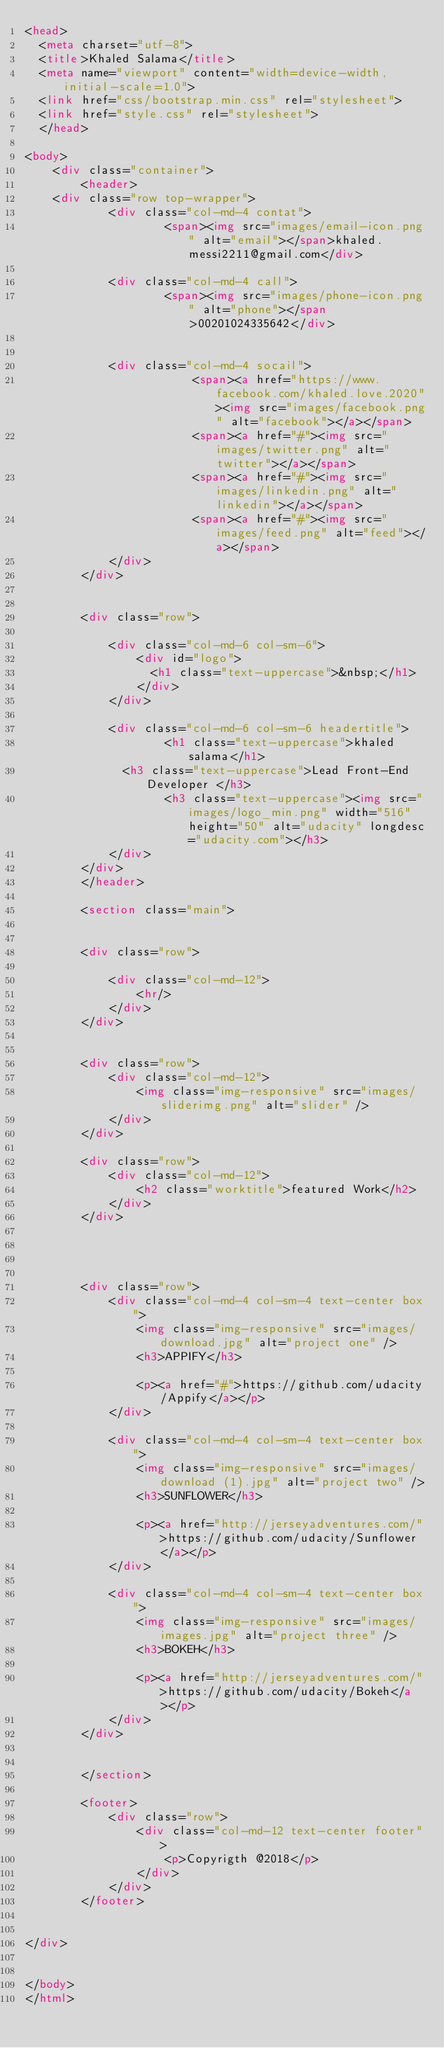Convert code to text. <code><loc_0><loc_0><loc_500><loc_500><_HTML_><head>
  <meta charset="utf-8">
  <title>Khaled Salama</title>
  <meta name="viewport" content="width=device-width, initial-scale=1.0">
  <link href="css/bootstrap.min.css" rel="stylesheet">
  <link href="style.css" rel="stylesheet">
  </head>

<body>
	<div class="container">
		<header>
	<div class="row top-wrapper">
        	<div class="col-md-4 contat">
                	<span><img src="images/email-icon.png" alt="email"></span>khaled.messi2211@gmail.com</div>
			
			<div class="col-md-4 call">
			     	<span><img src="images/phone-icon.png" alt="phone"></span>00201024335642</div>
        
            
            <div class="col-md-4 socail">
						<span><a href="https://www.facebook.com/khaled.love.2020"><img src="images/facebook.png" alt="facebook"></a></span>
                        <span><a href="#"><img src="images/twitter.png" alt="twitter"></a></span>
                        <span><a href="#"><img src="images/linkedin.png" alt="linkedin"></a></span>
                        <span><a href="#"><img src="images/feed.png" alt="feed"></a></span>
            </div>
        </div>

	
		<div class="row">
			
            <div class="col-md-6 col-sm-6">
				<div id="logo">
				  <h1 class="text-uppercase">&nbsp;</h1>
				</div>
            </div>
            
            <div class="col-md-6 col-sm-6 headertitle">
					<h1 class="text-uppercase">khaled salama</h1>
              <h3 class="text-uppercase">Lead Front-End Developer </h3>
                    <h3 class="text-uppercase"><img src="images/logo_min.png" width="516" height="50" alt="udacity" longdesc="udacity.com"></h3>
            </div>
        </div>
		</header>
		
		<section class="main">
		
			
		<div class="row">
			
            <div class="col-md-12">
				<hr/>
			</div>
		</div>
		
		
		<div class="row">
			<div class="col-md-12">
				<img class="img-responsive" src="images/sliderimg.png" alt="slider" />
			</div>
		</div>
		
		<div class="row">
			<div class="col-md-12">
				<h2 class="worktitle">featured Work</h2>
			</div>
		</div>
		
		
		
		
		<div class="row">
			<div class="col-md-4 col-sm-4 text-center box">
				<img class="img-responsive" src="images/download.jpg" alt="project one" />
				<h3>APPIFY</h3>
				
				<p><a href="#">https://github.com/udacity/Appify</a></p>
			</div>
			
			<div class="col-md-4 col-sm-4 text-center box">
				<img class="img-responsive" src="images/download (1).jpg" alt="project two" />
				<h3>SUNFLOWER</h3>
				
				<p><a href="http://jerseyadventures.com/">https://github.com/udacity/Sunflower</a></p>
			</div>
			
			<div class="col-md-4 col-sm-4 text-center box">
				<img class="img-responsive" src="images/images.jpg" alt="project three" />
				<h3>BOKEH</h3>
				
				<p><a href="http://jerseyadventures.com/">https://github.com/udacity/Bokeh</a></p>
			</div>
		</div>
		
		
		</section>
		
		<footer>
			<div class="row">
				<div class="col-md-12 text-center footer">
					<p>Copyrigth @2018</p>
				</div>
			</div>
		</footer>

	
</div>


</body>
</html>
</code> 